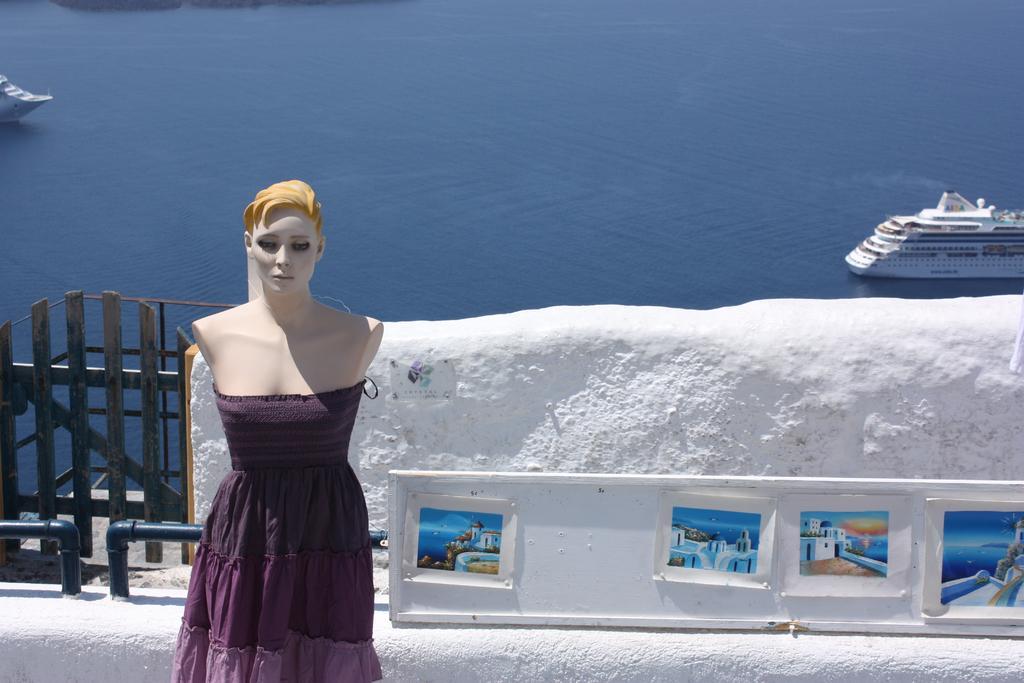Describe this image in one or two sentences. This is a mannequin and there is a ship on the water. Here we can see posts, fence, and a wall. 